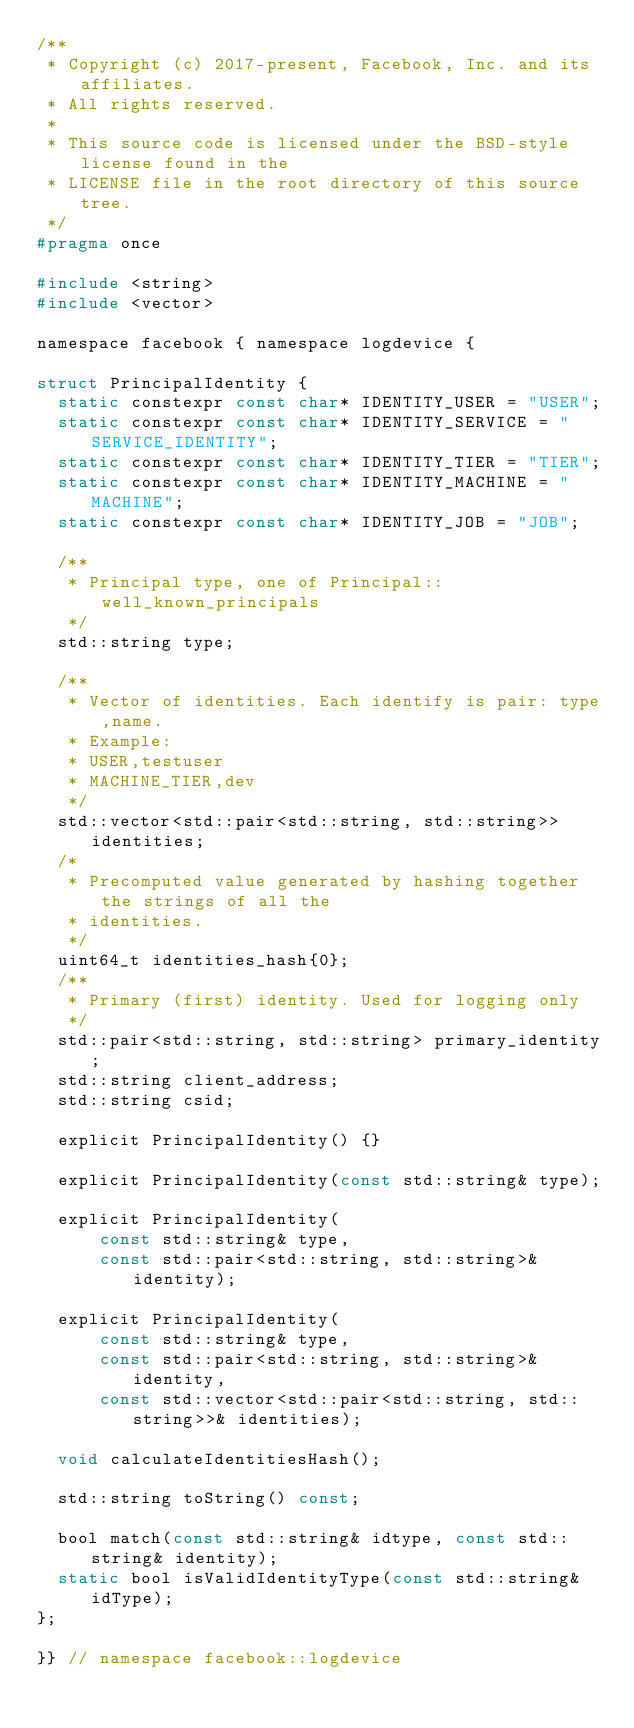Convert code to text. <code><loc_0><loc_0><loc_500><loc_500><_C_>/**
 * Copyright (c) 2017-present, Facebook, Inc. and its affiliates.
 * All rights reserved.
 *
 * This source code is licensed under the BSD-style license found in the
 * LICENSE file in the root directory of this source tree.
 */
#pragma once

#include <string>
#include <vector>

namespace facebook { namespace logdevice {

struct PrincipalIdentity {
  static constexpr const char* IDENTITY_USER = "USER";
  static constexpr const char* IDENTITY_SERVICE = "SERVICE_IDENTITY";
  static constexpr const char* IDENTITY_TIER = "TIER";
  static constexpr const char* IDENTITY_MACHINE = "MACHINE";
  static constexpr const char* IDENTITY_JOB = "JOB";

  /**
   * Principal type, one of Principal::well_known_principals
   */
  std::string type;

  /**
   * Vector of identities. Each identify is pair: type,name.
   * Example:
   * USER,testuser
   * MACHINE_TIER,dev
   */
  std::vector<std::pair<std::string, std::string>> identities;
  /*
   * Precomputed value generated by hashing together the strings of all the
   * identities.
   */
  uint64_t identities_hash{0};
  /**
   * Primary (first) identity. Used for logging only
   */
  std::pair<std::string, std::string> primary_identity;
  std::string client_address;
  std::string csid;

  explicit PrincipalIdentity() {}

  explicit PrincipalIdentity(const std::string& type);

  explicit PrincipalIdentity(
      const std::string& type,
      const std::pair<std::string, std::string>& identity);

  explicit PrincipalIdentity(
      const std::string& type,
      const std::pair<std::string, std::string>& identity,
      const std::vector<std::pair<std::string, std::string>>& identities);

  void calculateIdentitiesHash();

  std::string toString() const;

  bool match(const std::string& idtype, const std::string& identity);
  static bool isValidIdentityType(const std::string& idType);
};

}} // namespace facebook::logdevice
</code> 